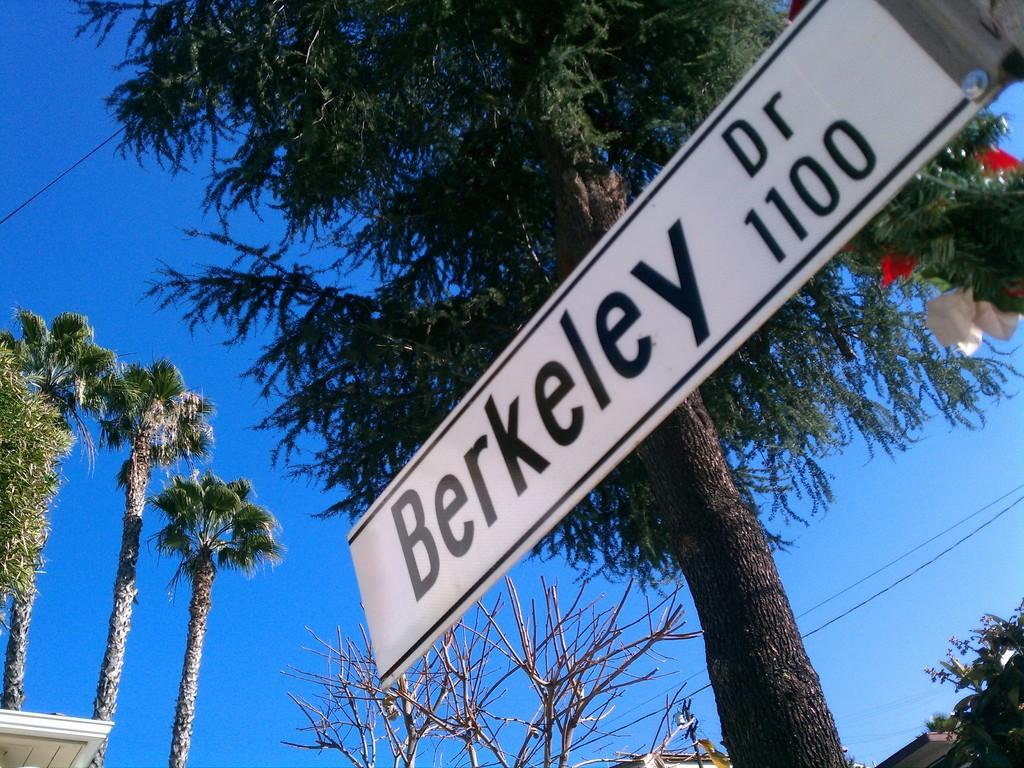What is the main object in the image? There is a white color hoarding in the image. How is the hoarding positioned in the image? The hoarding is attached to a pole. What can be seen in the background of the image? There are trees and a blue sky in the background of the image. How much profit does the bike generate in the image? There is no bike present in the image, so it is not possible to determine any profit generated. 